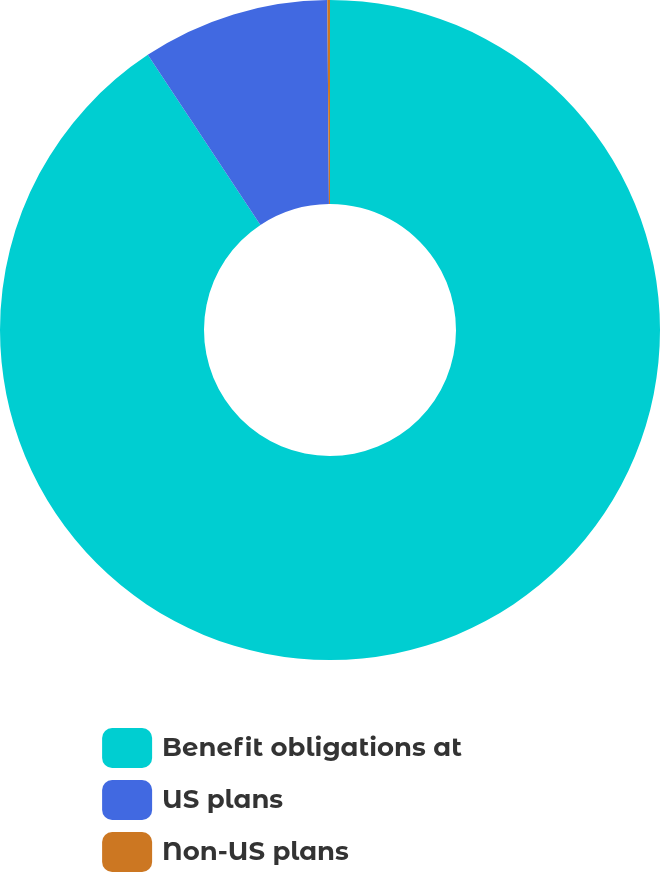Convert chart. <chart><loc_0><loc_0><loc_500><loc_500><pie_chart><fcel>Benefit obligations at<fcel>US plans<fcel>Non-US plans<nl><fcel>90.69%<fcel>9.18%<fcel>0.13%<nl></chart> 